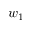Convert formula to latex. <formula><loc_0><loc_0><loc_500><loc_500>w _ { 1 }</formula> 